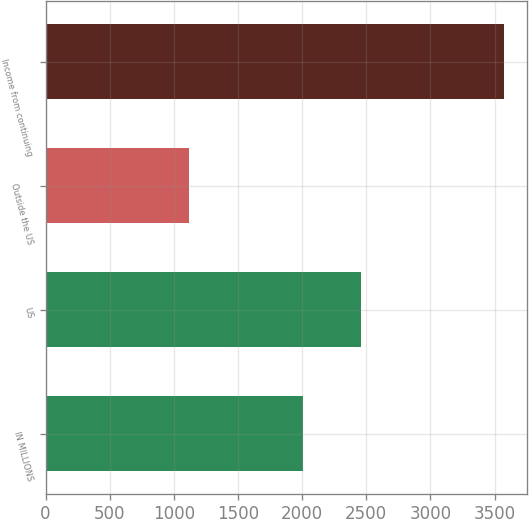<chart> <loc_0><loc_0><loc_500><loc_500><bar_chart><fcel>IN MILLIONS<fcel>US<fcel>Outside the US<fcel>Income from continuing<nl><fcel>2007<fcel>2455<fcel>1117.1<fcel>3572.1<nl></chart> 